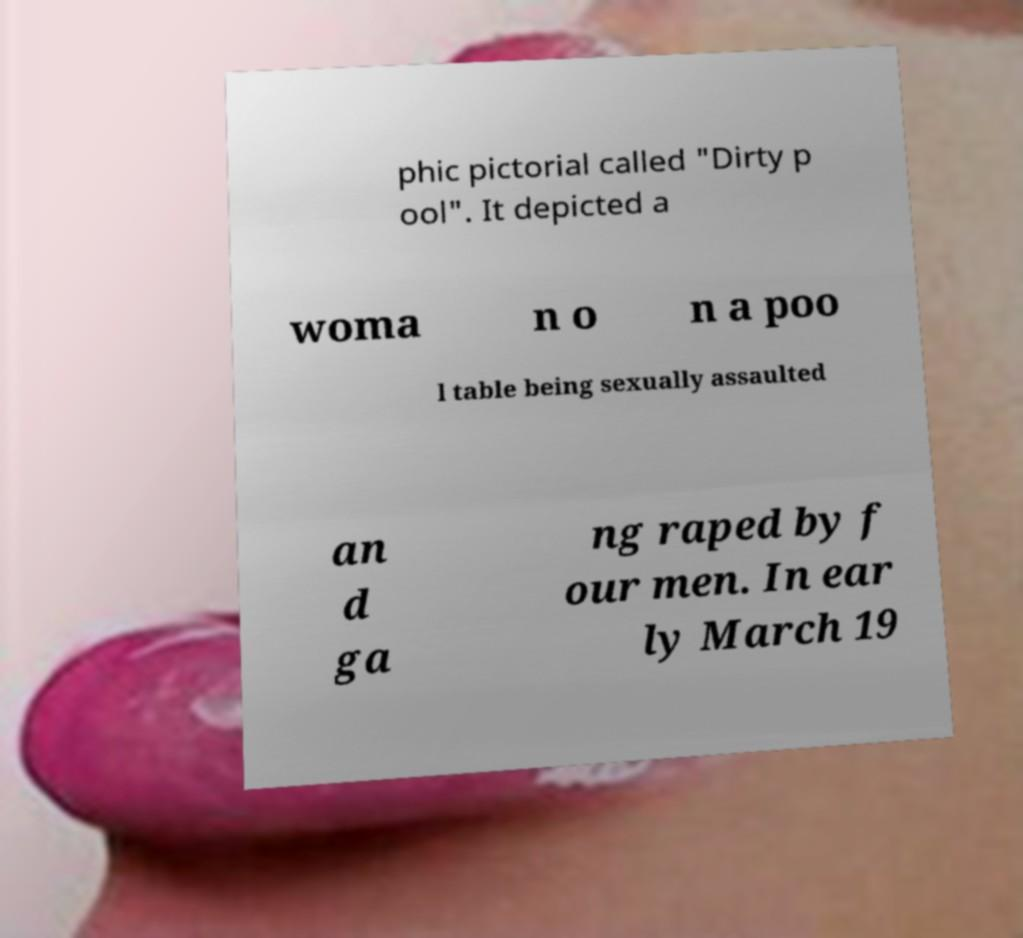What messages or text are displayed in this image? I need them in a readable, typed format. phic pictorial called "Dirty p ool". It depicted a woma n o n a poo l table being sexually assaulted an d ga ng raped by f our men. In ear ly March 19 